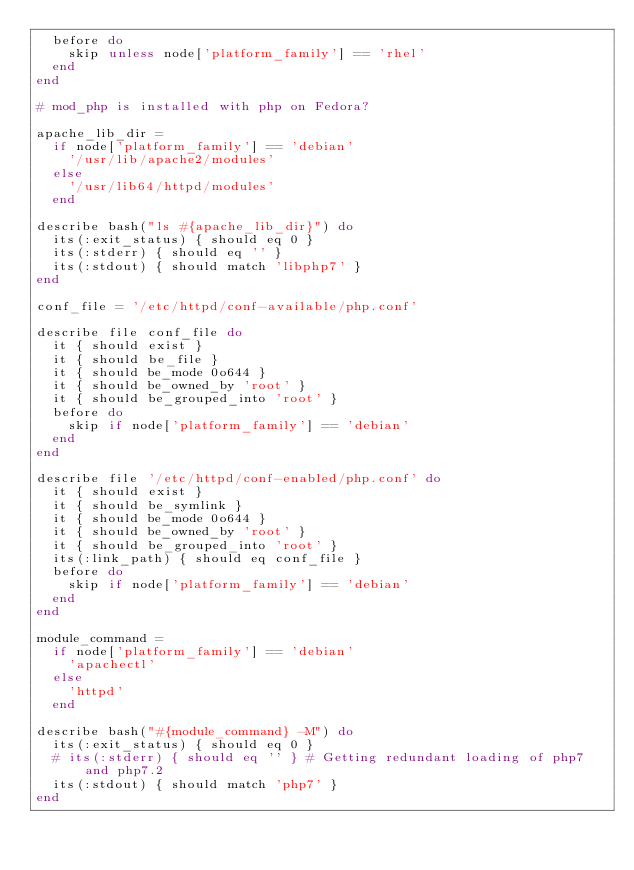Convert code to text. <code><loc_0><loc_0><loc_500><loc_500><_Ruby_>  before do
    skip unless node['platform_family'] == 'rhel'
  end
end

# mod_php is installed with php on Fedora?

apache_lib_dir =
  if node['platform_family'] == 'debian'
    '/usr/lib/apache2/modules'
  else
    '/usr/lib64/httpd/modules'
  end

describe bash("ls #{apache_lib_dir}") do
  its(:exit_status) { should eq 0 }
  its(:stderr) { should eq '' }
  its(:stdout) { should match 'libphp7' }
end

conf_file = '/etc/httpd/conf-available/php.conf'

describe file conf_file do
  it { should exist }
  it { should be_file }
  it { should be_mode 0o644 }
  it { should be_owned_by 'root' }
  it { should be_grouped_into 'root' }
  before do
    skip if node['platform_family'] == 'debian'
  end
end

describe file '/etc/httpd/conf-enabled/php.conf' do
  it { should exist }
  it { should be_symlink }
  it { should be_mode 0o644 }
  it { should be_owned_by 'root' }
  it { should be_grouped_into 'root' }
  its(:link_path) { should eq conf_file }
  before do
    skip if node['platform_family'] == 'debian'
  end
end

module_command =
  if node['platform_family'] == 'debian'
    'apachectl'
  else
    'httpd'
  end

describe bash("#{module_command} -M") do
  its(:exit_status) { should eq 0 }
  # its(:stderr) { should eq '' } # Getting redundant loading of php7 and php7.2
  its(:stdout) { should match 'php7' }
end
</code> 